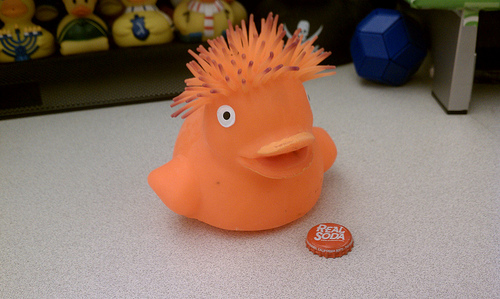<image>
Is the duck on the bottlecap? No. The duck is not positioned on the bottlecap. They may be near each other, but the duck is not supported by or resting on top of the bottlecap. Where is the flat in relation to the doll? Is it on the doll? No. The flat is not positioned on the doll. They may be near each other, but the flat is not supported by or resting on top of the doll. Where is the toy in relation to the bottle cap? Is it in front of the bottle cap? No. The toy is not in front of the bottle cap. The spatial positioning shows a different relationship between these objects. 